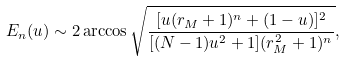<formula> <loc_0><loc_0><loc_500><loc_500>E _ { n } ( u ) \sim 2 \arccos \sqrt { \frac { [ u ( r _ { M } + 1 ) ^ { n } + ( 1 - u ) ] ^ { 2 } } { [ ( N - 1 ) u ^ { 2 } + 1 ] ( r _ { M } ^ { 2 } + 1 ) ^ { n } } } ,</formula> 